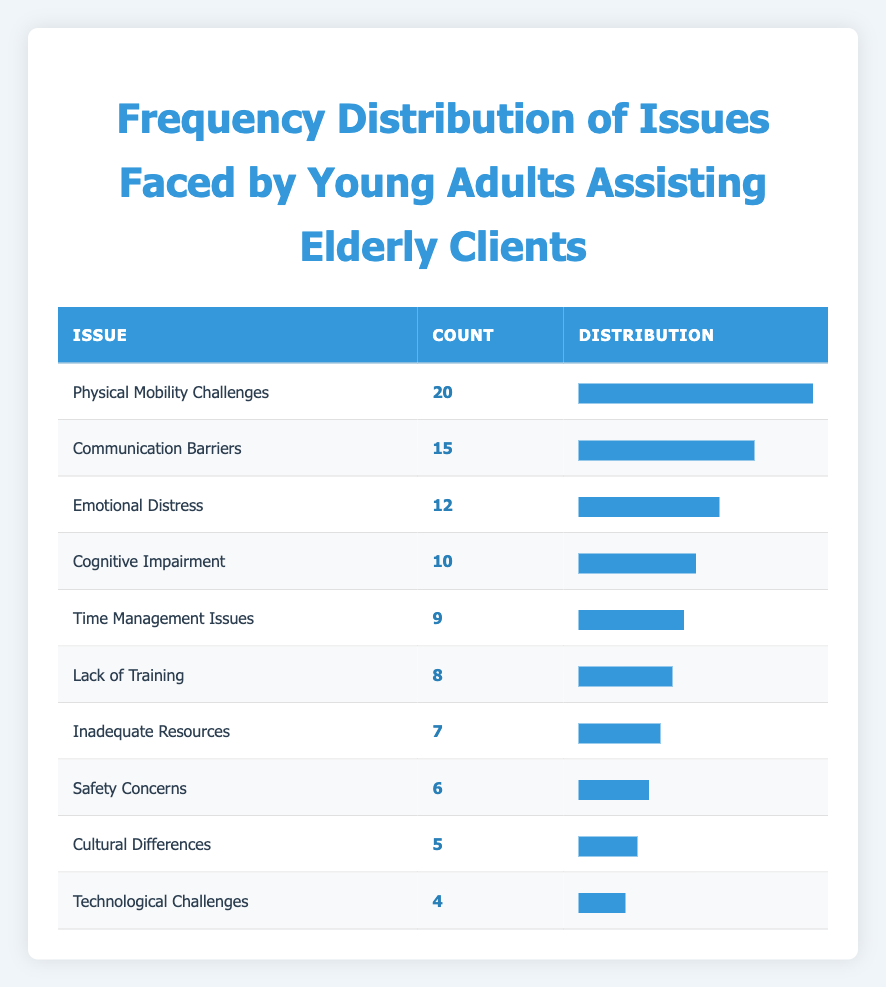What is the issue reported most frequently by young adults assisting elderly clients? The table shows the count of reported issues faced by young adults. The issue with the highest count is "Physical Mobility Challenges," which has a count of 20.
Answer: Physical Mobility Challenges How many reported issues are there in total? To find the total number of reported issues, we need to sum the counts for all issues listed in the table: 20 + 15 + 12 + 10 + 9 + 8 + 7 + 6 + 5 + 4 = 96.
Answer: 96 Is "Technological Challenges" one of the top three issues faced by young adults? By examining the counts, "Technological Challenges" has a count of 4, which is the lowest and not in the top three issues. The top three issues, in order, are "Physical Mobility Challenges," "Communication Barriers," and "Emotional Distress."
Answer: No What percentage of the total issues does "Emotional Distress" represent? First, we need to find the count of "Emotional Distress," which is 12. The total number of issues is 96 (previous question). To find the percentage, we calculate (12 / 96) * 100 = 12.5%.
Answer: 12.5% How many more young adults reported "Communication Barriers" than "Cultural Differences"? The count for "Communication Barriers" is 15, and for "Cultural Differences," it is 5. The difference is calculated as 15 - 5 = 10.
Answer: 10 What is the average count of issues reported by young adults assisting elderly clients? To calculate the average, we first need the total count of issues (96) and divide it by the number of unique issues listed, which is 10. Therefore, the average count is 96 / 10 = 9.6.
Answer: 9.6 Which reported issue has the lowest count, and how many reported it? The issue with the lowest count is "Technological Challenges," which has a count of 4.
Answer: Technological Challenges, 4 Is the count of reported "Safety Concerns" greater than that of "Inadequate Resources"? The count for "Safety Concerns" is 6, while for "Inadequate Resources" it is 7. Since 6 is not greater than 7, the statement is false.
Answer: No 